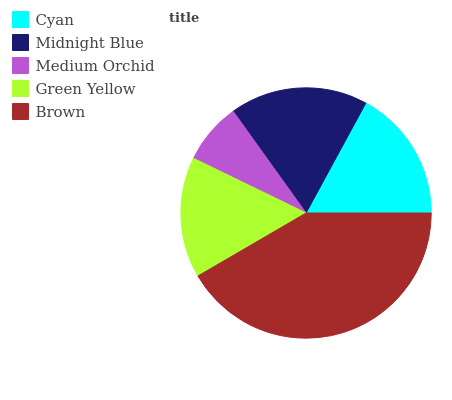Is Medium Orchid the minimum?
Answer yes or no. Yes. Is Brown the maximum?
Answer yes or no. Yes. Is Midnight Blue the minimum?
Answer yes or no. No. Is Midnight Blue the maximum?
Answer yes or no. No. Is Midnight Blue greater than Cyan?
Answer yes or no. Yes. Is Cyan less than Midnight Blue?
Answer yes or no. Yes. Is Cyan greater than Midnight Blue?
Answer yes or no. No. Is Midnight Blue less than Cyan?
Answer yes or no. No. Is Cyan the high median?
Answer yes or no. Yes. Is Cyan the low median?
Answer yes or no. Yes. Is Medium Orchid the high median?
Answer yes or no. No. Is Brown the low median?
Answer yes or no. No. 